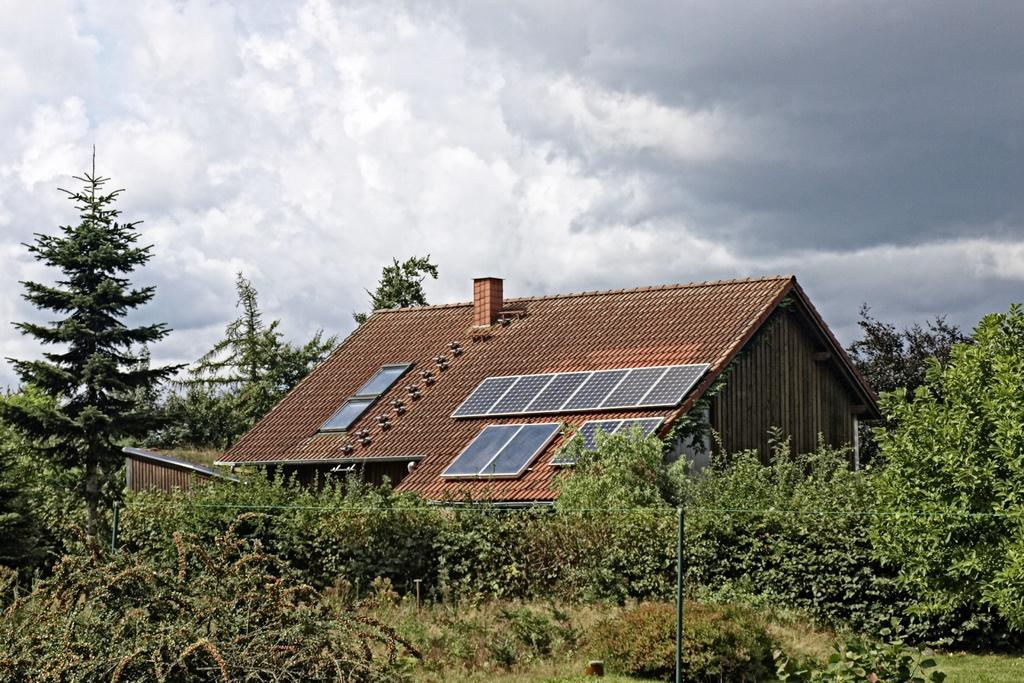What type of structure is visible in the image? There is a house in the image. What type of vegetation can be seen in the image? There is grass, plants, and trees in the image. What are the rods used for in the image? The purpose of the rods is not specified in the image. What is visible in the background of the image? The sky is visible in the background of the image. What can be seen in the sky? There are clouds in the sky. What type of stem can be seen growing from the house in the image? There is no stem growing from the house in the image. What hope does the image convey to the viewer? The image does not convey any specific hope or message; it is a visual representation of a house, vegetation, and the sky. 